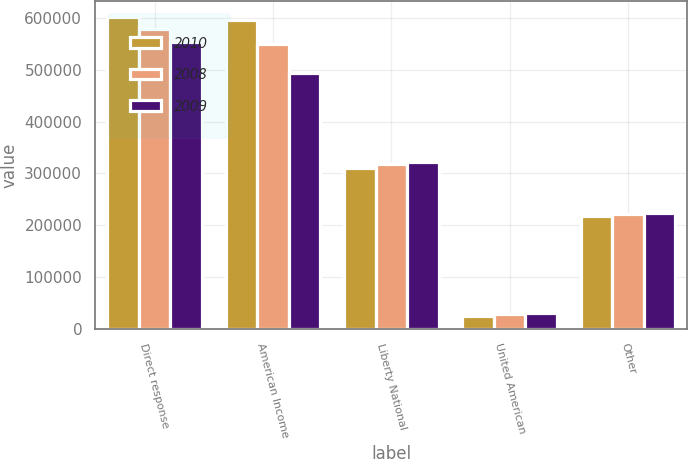Convert chart to OTSL. <chart><loc_0><loc_0><loc_500><loc_500><stacked_bar_chart><ecel><fcel>Direct response<fcel>American Income<fcel>Liberty National<fcel>United American<fcel>Other<nl><fcel>2010<fcel>602593<fcel>596583<fcel>310475<fcel>24726<fcel>218669<nl><fcel>2008<fcel>578223<fcel>549540<fcel>317413<fcel>27740<fcel>221486<nl><fcel>2009<fcel>553740<fcel>494191<fcel>322179<fcel>30998<fcel>224441<nl></chart> 